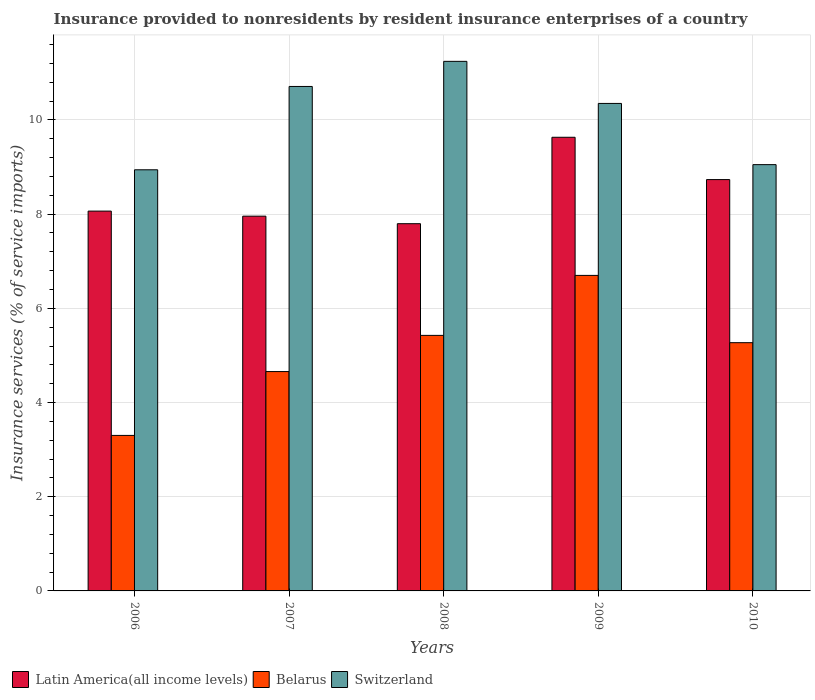How many different coloured bars are there?
Offer a terse response. 3. How many groups of bars are there?
Your response must be concise. 5. Are the number of bars per tick equal to the number of legend labels?
Ensure brevity in your answer.  Yes. Are the number of bars on each tick of the X-axis equal?
Give a very brief answer. Yes. How many bars are there on the 1st tick from the right?
Your answer should be compact. 3. What is the label of the 5th group of bars from the left?
Ensure brevity in your answer.  2010. In how many cases, is the number of bars for a given year not equal to the number of legend labels?
Give a very brief answer. 0. What is the insurance provided to nonresidents in Latin America(all income levels) in 2006?
Your answer should be compact. 8.06. Across all years, what is the maximum insurance provided to nonresidents in Belarus?
Make the answer very short. 6.7. Across all years, what is the minimum insurance provided to nonresidents in Switzerland?
Give a very brief answer. 8.94. In which year was the insurance provided to nonresidents in Latin America(all income levels) maximum?
Keep it short and to the point. 2009. In which year was the insurance provided to nonresidents in Latin America(all income levels) minimum?
Your answer should be very brief. 2008. What is the total insurance provided to nonresidents in Latin America(all income levels) in the graph?
Ensure brevity in your answer.  42.19. What is the difference between the insurance provided to nonresidents in Switzerland in 2007 and that in 2009?
Provide a succinct answer. 0.36. What is the difference between the insurance provided to nonresidents in Latin America(all income levels) in 2007 and the insurance provided to nonresidents in Belarus in 2006?
Provide a succinct answer. 4.66. What is the average insurance provided to nonresidents in Latin America(all income levels) per year?
Ensure brevity in your answer.  8.44. In the year 2010, what is the difference between the insurance provided to nonresidents in Belarus and insurance provided to nonresidents in Latin America(all income levels)?
Offer a terse response. -3.46. What is the ratio of the insurance provided to nonresidents in Switzerland in 2006 to that in 2010?
Offer a very short reply. 0.99. What is the difference between the highest and the second highest insurance provided to nonresidents in Switzerland?
Make the answer very short. 0.53. What is the difference between the highest and the lowest insurance provided to nonresidents in Latin America(all income levels)?
Keep it short and to the point. 1.84. Is the sum of the insurance provided to nonresidents in Switzerland in 2007 and 2010 greater than the maximum insurance provided to nonresidents in Latin America(all income levels) across all years?
Provide a short and direct response. Yes. What does the 3rd bar from the left in 2008 represents?
Offer a terse response. Switzerland. What does the 1st bar from the right in 2008 represents?
Your answer should be compact. Switzerland. Is it the case that in every year, the sum of the insurance provided to nonresidents in Switzerland and insurance provided to nonresidents in Latin America(all income levels) is greater than the insurance provided to nonresidents in Belarus?
Your answer should be very brief. Yes. Are all the bars in the graph horizontal?
Make the answer very short. No. Are the values on the major ticks of Y-axis written in scientific E-notation?
Provide a succinct answer. No. Where does the legend appear in the graph?
Your answer should be compact. Bottom left. How are the legend labels stacked?
Give a very brief answer. Horizontal. What is the title of the graph?
Give a very brief answer. Insurance provided to nonresidents by resident insurance enterprises of a country. What is the label or title of the X-axis?
Ensure brevity in your answer.  Years. What is the label or title of the Y-axis?
Keep it short and to the point. Insurance services (% of service imports). What is the Insurance services (% of service imports) of Latin America(all income levels) in 2006?
Your answer should be compact. 8.06. What is the Insurance services (% of service imports) in Belarus in 2006?
Your answer should be very brief. 3.3. What is the Insurance services (% of service imports) in Switzerland in 2006?
Provide a succinct answer. 8.94. What is the Insurance services (% of service imports) of Latin America(all income levels) in 2007?
Make the answer very short. 7.96. What is the Insurance services (% of service imports) of Belarus in 2007?
Offer a very short reply. 4.66. What is the Insurance services (% of service imports) in Switzerland in 2007?
Your answer should be compact. 10.71. What is the Insurance services (% of service imports) in Latin America(all income levels) in 2008?
Offer a very short reply. 7.8. What is the Insurance services (% of service imports) of Belarus in 2008?
Give a very brief answer. 5.43. What is the Insurance services (% of service imports) of Switzerland in 2008?
Ensure brevity in your answer.  11.24. What is the Insurance services (% of service imports) of Latin America(all income levels) in 2009?
Ensure brevity in your answer.  9.63. What is the Insurance services (% of service imports) in Belarus in 2009?
Give a very brief answer. 6.7. What is the Insurance services (% of service imports) in Switzerland in 2009?
Keep it short and to the point. 10.35. What is the Insurance services (% of service imports) of Latin America(all income levels) in 2010?
Make the answer very short. 8.73. What is the Insurance services (% of service imports) of Belarus in 2010?
Offer a very short reply. 5.27. What is the Insurance services (% of service imports) of Switzerland in 2010?
Offer a terse response. 9.05. Across all years, what is the maximum Insurance services (% of service imports) in Latin America(all income levels)?
Ensure brevity in your answer.  9.63. Across all years, what is the maximum Insurance services (% of service imports) in Belarus?
Offer a very short reply. 6.7. Across all years, what is the maximum Insurance services (% of service imports) in Switzerland?
Ensure brevity in your answer.  11.24. Across all years, what is the minimum Insurance services (% of service imports) of Latin America(all income levels)?
Make the answer very short. 7.8. Across all years, what is the minimum Insurance services (% of service imports) of Belarus?
Your answer should be compact. 3.3. Across all years, what is the minimum Insurance services (% of service imports) in Switzerland?
Provide a succinct answer. 8.94. What is the total Insurance services (% of service imports) of Latin America(all income levels) in the graph?
Your answer should be very brief. 42.19. What is the total Insurance services (% of service imports) of Belarus in the graph?
Provide a short and direct response. 25.36. What is the total Insurance services (% of service imports) in Switzerland in the graph?
Keep it short and to the point. 50.3. What is the difference between the Insurance services (% of service imports) of Latin America(all income levels) in 2006 and that in 2007?
Provide a short and direct response. 0.11. What is the difference between the Insurance services (% of service imports) in Belarus in 2006 and that in 2007?
Keep it short and to the point. -1.36. What is the difference between the Insurance services (% of service imports) in Switzerland in 2006 and that in 2007?
Give a very brief answer. -1.77. What is the difference between the Insurance services (% of service imports) of Latin America(all income levels) in 2006 and that in 2008?
Your answer should be very brief. 0.27. What is the difference between the Insurance services (% of service imports) in Belarus in 2006 and that in 2008?
Make the answer very short. -2.12. What is the difference between the Insurance services (% of service imports) in Switzerland in 2006 and that in 2008?
Provide a short and direct response. -2.3. What is the difference between the Insurance services (% of service imports) in Latin America(all income levels) in 2006 and that in 2009?
Provide a succinct answer. -1.57. What is the difference between the Insurance services (% of service imports) of Belarus in 2006 and that in 2009?
Ensure brevity in your answer.  -3.4. What is the difference between the Insurance services (% of service imports) in Switzerland in 2006 and that in 2009?
Provide a short and direct response. -1.41. What is the difference between the Insurance services (% of service imports) of Latin America(all income levels) in 2006 and that in 2010?
Give a very brief answer. -0.67. What is the difference between the Insurance services (% of service imports) of Belarus in 2006 and that in 2010?
Provide a succinct answer. -1.97. What is the difference between the Insurance services (% of service imports) in Switzerland in 2006 and that in 2010?
Give a very brief answer. -0.11. What is the difference between the Insurance services (% of service imports) of Latin America(all income levels) in 2007 and that in 2008?
Provide a short and direct response. 0.16. What is the difference between the Insurance services (% of service imports) of Belarus in 2007 and that in 2008?
Provide a succinct answer. -0.77. What is the difference between the Insurance services (% of service imports) of Switzerland in 2007 and that in 2008?
Give a very brief answer. -0.53. What is the difference between the Insurance services (% of service imports) of Latin America(all income levels) in 2007 and that in 2009?
Keep it short and to the point. -1.68. What is the difference between the Insurance services (% of service imports) of Belarus in 2007 and that in 2009?
Provide a short and direct response. -2.04. What is the difference between the Insurance services (% of service imports) in Switzerland in 2007 and that in 2009?
Give a very brief answer. 0.36. What is the difference between the Insurance services (% of service imports) of Latin America(all income levels) in 2007 and that in 2010?
Ensure brevity in your answer.  -0.78. What is the difference between the Insurance services (% of service imports) of Belarus in 2007 and that in 2010?
Make the answer very short. -0.61. What is the difference between the Insurance services (% of service imports) of Switzerland in 2007 and that in 2010?
Keep it short and to the point. 1.66. What is the difference between the Insurance services (% of service imports) of Latin America(all income levels) in 2008 and that in 2009?
Your answer should be very brief. -1.84. What is the difference between the Insurance services (% of service imports) in Belarus in 2008 and that in 2009?
Your answer should be compact. -1.27. What is the difference between the Insurance services (% of service imports) of Switzerland in 2008 and that in 2009?
Provide a short and direct response. 0.89. What is the difference between the Insurance services (% of service imports) in Latin America(all income levels) in 2008 and that in 2010?
Provide a succinct answer. -0.94. What is the difference between the Insurance services (% of service imports) in Belarus in 2008 and that in 2010?
Make the answer very short. 0.15. What is the difference between the Insurance services (% of service imports) of Switzerland in 2008 and that in 2010?
Your response must be concise. 2.19. What is the difference between the Insurance services (% of service imports) in Latin America(all income levels) in 2009 and that in 2010?
Offer a very short reply. 0.9. What is the difference between the Insurance services (% of service imports) in Belarus in 2009 and that in 2010?
Provide a succinct answer. 1.43. What is the difference between the Insurance services (% of service imports) of Switzerland in 2009 and that in 2010?
Give a very brief answer. 1.3. What is the difference between the Insurance services (% of service imports) of Latin America(all income levels) in 2006 and the Insurance services (% of service imports) of Belarus in 2007?
Your answer should be compact. 3.41. What is the difference between the Insurance services (% of service imports) of Latin America(all income levels) in 2006 and the Insurance services (% of service imports) of Switzerland in 2007?
Provide a succinct answer. -2.65. What is the difference between the Insurance services (% of service imports) in Belarus in 2006 and the Insurance services (% of service imports) in Switzerland in 2007?
Ensure brevity in your answer.  -7.41. What is the difference between the Insurance services (% of service imports) of Latin America(all income levels) in 2006 and the Insurance services (% of service imports) of Belarus in 2008?
Offer a very short reply. 2.64. What is the difference between the Insurance services (% of service imports) in Latin America(all income levels) in 2006 and the Insurance services (% of service imports) in Switzerland in 2008?
Your answer should be very brief. -3.18. What is the difference between the Insurance services (% of service imports) in Belarus in 2006 and the Insurance services (% of service imports) in Switzerland in 2008?
Your answer should be very brief. -7.94. What is the difference between the Insurance services (% of service imports) in Latin America(all income levels) in 2006 and the Insurance services (% of service imports) in Belarus in 2009?
Your response must be concise. 1.37. What is the difference between the Insurance services (% of service imports) of Latin America(all income levels) in 2006 and the Insurance services (% of service imports) of Switzerland in 2009?
Offer a very short reply. -2.29. What is the difference between the Insurance services (% of service imports) in Belarus in 2006 and the Insurance services (% of service imports) in Switzerland in 2009?
Provide a short and direct response. -7.05. What is the difference between the Insurance services (% of service imports) in Latin America(all income levels) in 2006 and the Insurance services (% of service imports) in Belarus in 2010?
Offer a very short reply. 2.79. What is the difference between the Insurance services (% of service imports) of Latin America(all income levels) in 2006 and the Insurance services (% of service imports) of Switzerland in 2010?
Make the answer very short. -0.99. What is the difference between the Insurance services (% of service imports) of Belarus in 2006 and the Insurance services (% of service imports) of Switzerland in 2010?
Keep it short and to the point. -5.75. What is the difference between the Insurance services (% of service imports) in Latin America(all income levels) in 2007 and the Insurance services (% of service imports) in Belarus in 2008?
Your answer should be very brief. 2.53. What is the difference between the Insurance services (% of service imports) in Latin America(all income levels) in 2007 and the Insurance services (% of service imports) in Switzerland in 2008?
Your response must be concise. -3.29. What is the difference between the Insurance services (% of service imports) of Belarus in 2007 and the Insurance services (% of service imports) of Switzerland in 2008?
Your answer should be very brief. -6.59. What is the difference between the Insurance services (% of service imports) of Latin America(all income levels) in 2007 and the Insurance services (% of service imports) of Belarus in 2009?
Make the answer very short. 1.26. What is the difference between the Insurance services (% of service imports) in Latin America(all income levels) in 2007 and the Insurance services (% of service imports) in Switzerland in 2009?
Your answer should be very brief. -2.39. What is the difference between the Insurance services (% of service imports) in Belarus in 2007 and the Insurance services (% of service imports) in Switzerland in 2009?
Your answer should be compact. -5.69. What is the difference between the Insurance services (% of service imports) of Latin America(all income levels) in 2007 and the Insurance services (% of service imports) of Belarus in 2010?
Your answer should be very brief. 2.69. What is the difference between the Insurance services (% of service imports) in Latin America(all income levels) in 2007 and the Insurance services (% of service imports) in Switzerland in 2010?
Provide a short and direct response. -1.09. What is the difference between the Insurance services (% of service imports) in Belarus in 2007 and the Insurance services (% of service imports) in Switzerland in 2010?
Provide a short and direct response. -4.39. What is the difference between the Insurance services (% of service imports) of Latin America(all income levels) in 2008 and the Insurance services (% of service imports) of Belarus in 2009?
Your response must be concise. 1.1. What is the difference between the Insurance services (% of service imports) of Latin America(all income levels) in 2008 and the Insurance services (% of service imports) of Switzerland in 2009?
Provide a succinct answer. -2.55. What is the difference between the Insurance services (% of service imports) in Belarus in 2008 and the Insurance services (% of service imports) in Switzerland in 2009?
Provide a succinct answer. -4.93. What is the difference between the Insurance services (% of service imports) of Latin America(all income levels) in 2008 and the Insurance services (% of service imports) of Belarus in 2010?
Ensure brevity in your answer.  2.53. What is the difference between the Insurance services (% of service imports) in Latin America(all income levels) in 2008 and the Insurance services (% of service imports) in Switzerland in 2010?
Offer a terse response. -1.25. What is the difference between the Insurance services (% of service imports) of Belarus in 2008 and the Insurance services (% of service imports) of Switzerland in 2010?
Ensure brevity in your answer.  -3.63. What is the difference between the Insurance services (% of service imports) in Latin America(all income levels) in 2009 and the Insurance services (% of service imports) in Belarus in 2010?
Your answer should be compact. 4.36. What is the difference between the Insurance services (% of service imports) of Latin America(all income levels) in 2009 and the Insurance services (% of service imports) of Switzerland in 2010?
Make the answer very short. 0.58. What is the difference between the Insurance services (% of service imports) in Belarus in 2009 and the Insurance services (% of service imports) in Switzerland in 2010?
Provide a succinct answer. -2.35. What is the average Insurance services (% of service imports) in Latin America(all income levels) per year?
Your answer should be compact. 8.44. What is the average Insurance services (% of service imports) in Belarus per year?
Keep it short and to the point. 5.07. What is the average Insurance services (% of service imports) in Switzerland per year?
Offer a terse response. 10.06. In the year 2006, what is the difference between the Insurance services (% of service imports) of Latin America(all income levels) and Insurance services (% of service imports) of Belarus?
Your answer should be compact. 4.76. In the year 2006, what is the difference between the Insurance services (% of service imports) of Latin America(all income levels) and Insurance services (% of service imports) of Switzerland?
Keep it short and to the point. -0.88. In the year 2006, what is the difference between the Insurance services (% of service imports) of Belarus and Insurance services (% of service imports) of Switzerland?
Give a very brief answer. -5.64. In the year 2007, what is the difference between the Insurance services (% of service imports) in Latin America(all income levels) and Insurance services (% of service imports) in Belarus?
Keep it short and to the point. 3.3. In the year 2007, what is the difference between the Insurance services (% of service imports) of Latin America(all income levels) and Insurance services (% of service imports) of Switzerland?
Your answer should be very brief. -2.75. In the year 2007, what is the difference between the Insurance services (% of service imports) of Belarus and Insurance services (% of service imports) of Switzerland?
Offer a terse response. -6.05. In the year 2008, what is the difference between the Insurance services (% of service imports) of Latin America(all income levels) and Insurance services (% of service imports) of Belarus?
Ensure brevity in your answer.  2.37. In the year 2008, what is the difference between the Insurance services (% of service imports) in Latin America(all income levels) and Insurance services (% of service imports) in Switzerland?
Provide a succinct answer. -3.45. In the year 2008, what is the difference between the Insurance services (% of service imports) of Belarus and Insurance services (% of service imports) of Switzerland?
Give a very brief answer. -5.82. In the year 2009, what is the difference between the Insurance services (% of service imports) in Latin America(all income levels) and Insurance services (% of service imports) in Belarus?
Your answer should be very brief. 2.93. In the year 2009, what is the difference between the Insurance services (% of service imports) in Latin America(all income levels) and Insurance services (% of service imports) in Switzerland?
Offer a terse response. -0.72. In the year 2009, what is the difference between the Insurance services (% of service imports) in Belarus and Insurance services (% of service imports) in Switzerland?
Give a very brief answer. -3.65. In the year 2010, what is the difference between the Insurance services (% of service imports) in Latin America(all income levels) and Insurance services (% of service imports) in Belarus?
Your response must be concise. 3.46. In the year 2010, what is the difference between the Insurance services (% of service imports) in Latin America(all income levels) and Insurance services (% of service imports) in Switzerland?
Your answer should be very brief. -0.32. In the year 2010, what is the difference between the Insurance services (% of service imports) in Belarus and Insurance services (% of service imports) in Switzerland?
Offer a very short reply. -3.78. What is the ratio of the Insurance services (% of service imports) in Latin America(all income levels) in 2006 to that in 2007?
Provide a succinct answer. 1.01. What is the ratio of the Insurance services (% of service imports) in Belarus in 2006 to that in 2007?
Your answer should be very brief. 0.71. What is the ratio of the Insurance services (% of service imports) in Switzerland in 2006 to that in 2007?
Ensure brevity in your answer.  0.83. What is the ratio of the Insurance services (% of service imports) in Latin America(all income levels) in 2006 to that in 2008?
Ensure brevity in your answer.  1.03. What is the ratio of the Insurance services (% of service imports) in Belarus in 2006 to that in 2008?
Ensure brevity in your answer.  0.61. What is the ratio of the Insurance services (% of service imports) in Switzerland in 2006 to that in 2008?
Provide a short and direct response. 0.8. What is the ratio of the Insurance services (% of service imports) in Latin America(all income levels) in 2006 to that in 2009?
Make the answer very short. 0.84. What is the ratio of the Insurance services (% of service imports) in Belarus in 2006 to that in 2009?
Your response must be concise. 0.49. What is the ratio of the Insurance services (% of service imports) in Switzerland in 2006 to that in 2009?
Keep it short and to the point. 0.86. What is the ratio of the Insurance services (% of service imports) of Latin America(all income levels) in 2006 to that in 2010?
Provide a succinct answer. 0.92. What is the ratio of the Insurance services (% of service imports) in Belarus in 2006 to that in 2010?
Offer a terse response. 0.63. What is the ratio of the Insurance services (% of service imports) of Switzerland in 2006 to that in 2010?
Give a very brief answer. 0.99. What is the ratio of the Insurance services (% of service imports) of Latin America(all income levels) in 2007 to that in 2008?
Provide a short and direct response. 1.02. What is the ratio of the Insurance services (% of service imports) in Belarus in 2007 to that in 2008?
Give a very brief answer. 0.86. What is the ratio of the Insurance services (% of service imports) in Switzerland in 2007 to that in 2008?
Offer a very short reply. 0.95. What is the ratio of the Insurance services (% of service imports) of Latin America(all income levels) in 2007 to that in 2009?
Your response must be concise. 0.83. What is the ratio of the Insurance services (% of service imports) of Belarus in 2007 to that in 2009?
Offer a very short reply. 0.7. What is the ratio of the Insurance services (% of service imports) of Switzerland in 2007 to that in 2009?
Your response must be concise. 1.03. What is the ratio of the Insurance services (% of service imports) of Latin America(all income levels) in 2007 to that in 2010?
Ensure brevity in your answer.  0.91. What is the ratio of the Insurance services (% of service imports) of Belarus in 2007 to that in 2010?
Your answer should be compact. 0.88. What is the ratio of the Insurance services (% of service imports) in Switzerland in 2007 to that in 2010?
Give a very brief answer. 1.18. What is the ratio of the Insurance services (% of service imports) in Latin America(all income levels) in 2008 to that in 2009?
Ensure brevity in your answer.  0.81. What is the ratio of the Insurance services (% of service imports) in Belarus in 2008 to that in 2009?
Provide a short and direct response. 0.81. What is the ratio of the Insurance services (% of service imports) in Switzerland in 2008 to that in 2009?
Provide a succinct answer. 1.09. What is the ratio of the Insurance services (% of service imports) of Latin America(all income levels) in 2008 to that in 2010?
Make the answer very short. 0.89. What is the ratio of the Insurance services (% of service imports) in Belarus in 2008 to that in 2010?
Offer a very short reply. 1.03. What is the ratio of the Insurance services (% of service imports) of Switzerland in 2008 to that in 2010?
Your answer should be compact. 1.24. What is the ratio of the Insurance services (% of service imports) in Latin America(all income levels) in 2009 to that in 2010?
Your answer should be very brief. 1.1. What is the ratio of the Insurance services (% of service imports) in Belarus in 2009 to that in 2010?
Make the answer very short. 1.27. What is the ratio of the Insurance services (% of service imports) in Switzerland in 2009 to that in 2010?
Provide a succinct answer. 1.14. What is the difference between the highest and the second highest Insurance services (% of service imports) in Latin America(all income levels)?
Your response must be concise. 0.9. What is the difference between the highest and the second highest Insurance services (% of service imports) of Belarus?
Ensure brevity in your answer.  1.27. What is the difference between the highest and the second highest Insurance services (% of service imports) of Switzerland?
Your answer should be compact. 0.53. What is the difference between the highest and the lowest Insurance services (% of service imports) of Latin America(all income levels)?
Make the answer very short. 1.84. What is the difference between the highest and the lowest Insurance services (% of service imports) in Belarus?
Your answer should be compact. 3.4. What is the difference between the highest and the lowest Insurance services (% of service imports) of Switzerland?
Ensure brevity in your answer.  2.3. 